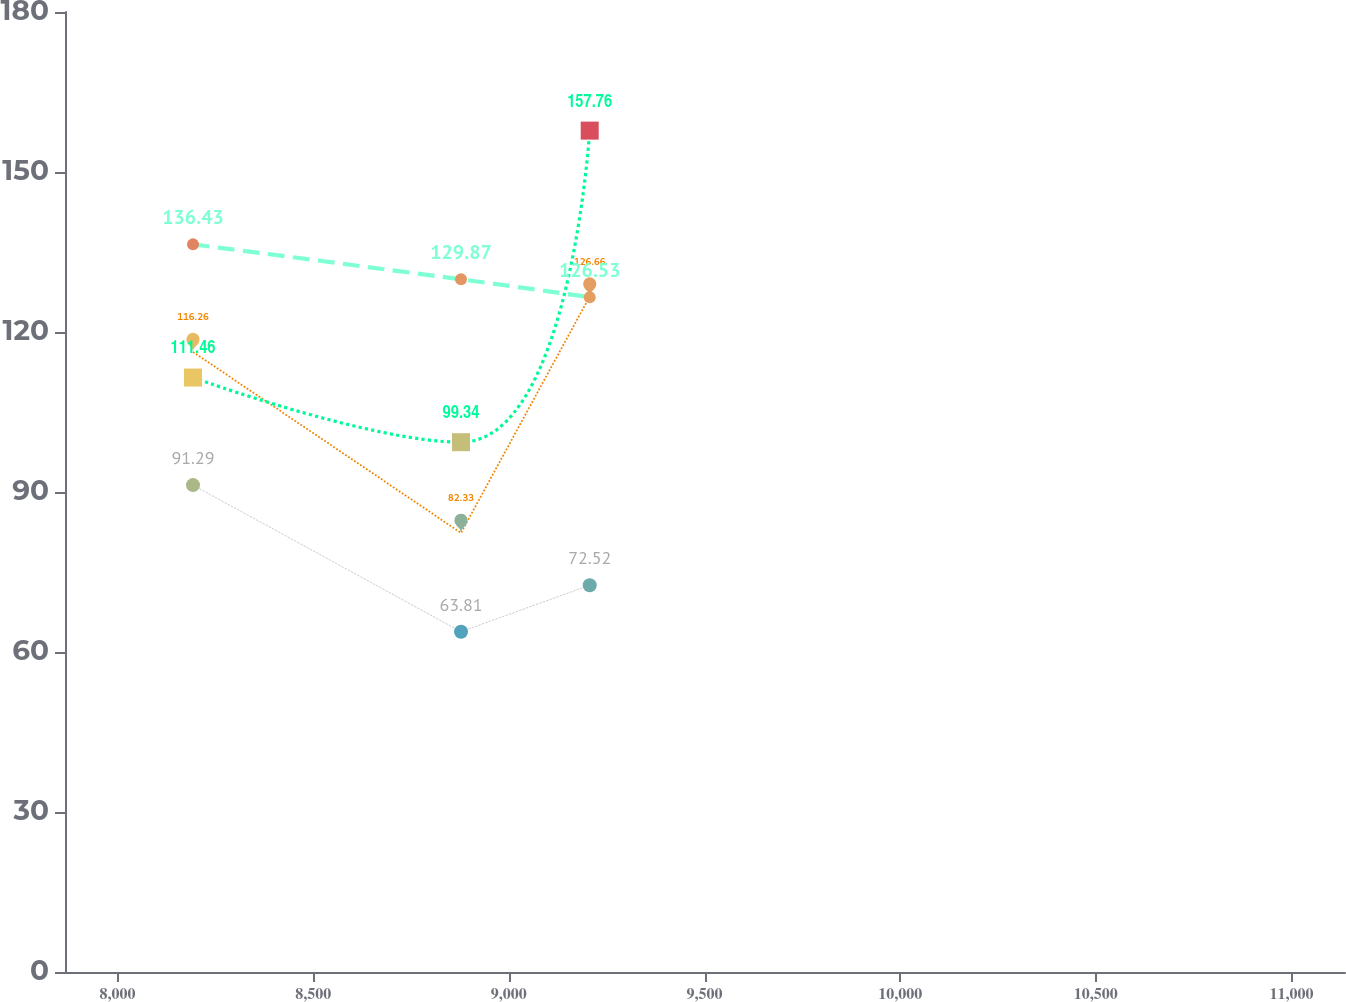Convert chart to OTSL. <chart><loc_0><loc_0><loc_500><loc_500><line_chart><ecel><fcel>1 2/02<fcel>12/03<fcel>12/04 1<fcel>1 2/06<nl><fcel>8192.91<fcel>91.29<fcel>116.26<fcel>111.46<fcel>136.43<nl><fcel>8877.76<fcel>63.81<fcel>82.33<fcel>99.34<fcel>129.87<nl><fcel>9206.67<fcel>72.52<fcel>126.66<fcel>157.76<fcel>126.53<nl><fcel>11463.8<fcel>100.2<fcel>99.19<fcel>117.3<fcel>125.11<nl></chart> 